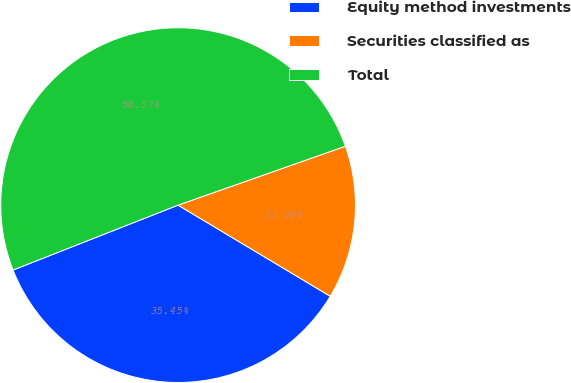Convert chart to OTSL. <chart><loc_0><loc_0><loc_500><loc_500><pie_chart><fcel>Equity method investments<fcel>Securities classified as<fcel>Total<nl><fcel>35.45%<fcel>13.98%<fcel>50.57%<nl></chart> 